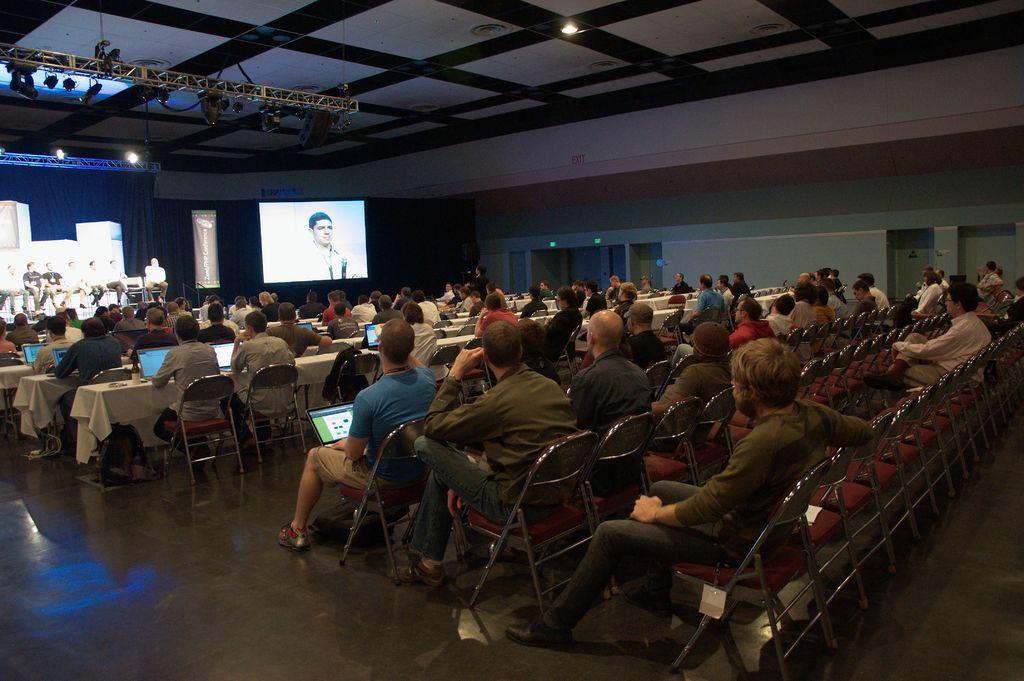Describe this image in one or two sentences. In the image there are many people sitting on chairs with laptops in front of them staring in the front, there is a screen in the back with some people standing and sitting on the stage on left side. 